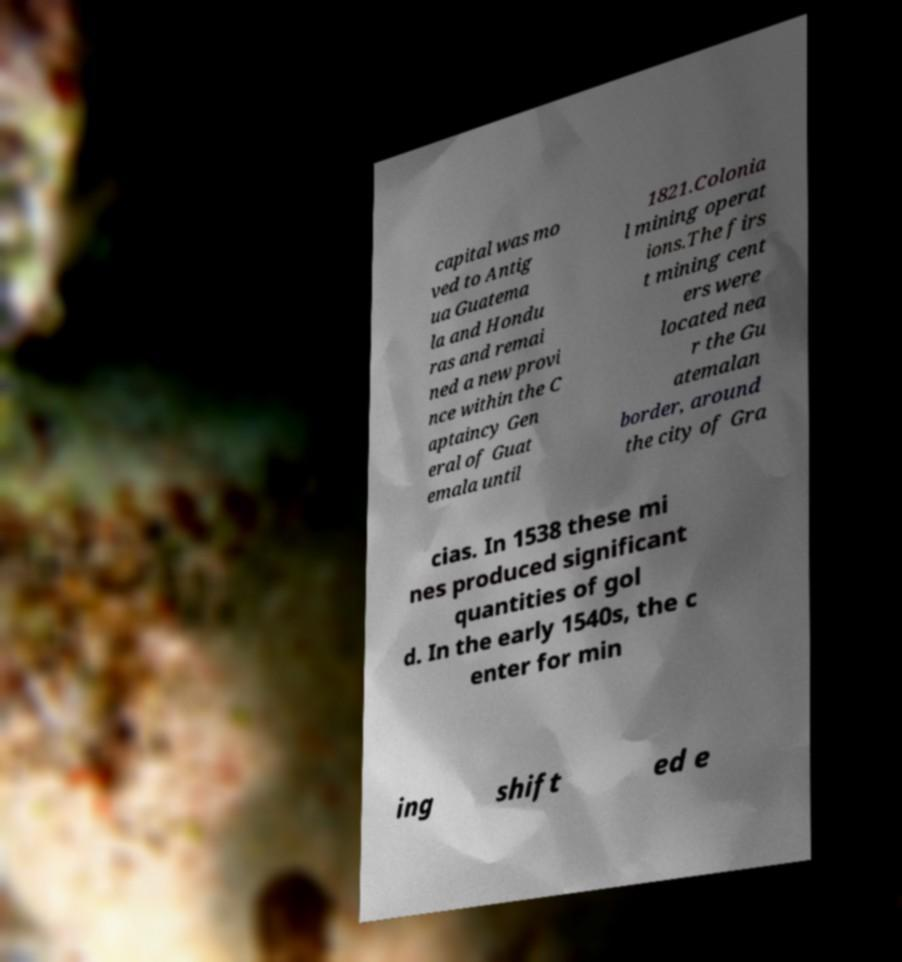What messages or text are displayed in this image? I need them in a readable, typed format. capital was mo ved to Antig ua Guatema la and Hondu ras and remai ned a new provi nce within the C aptaincy Gen eral of Guat emala until 1821.Colonia l mining operat ions.The firs t mining cent ers were located nea r the Gu atemalan border, around the city of Gra cias. In 1538 these mi nes produced significant quantities of gol d. In the early 1540s, the c enter for min ing shift ed e 